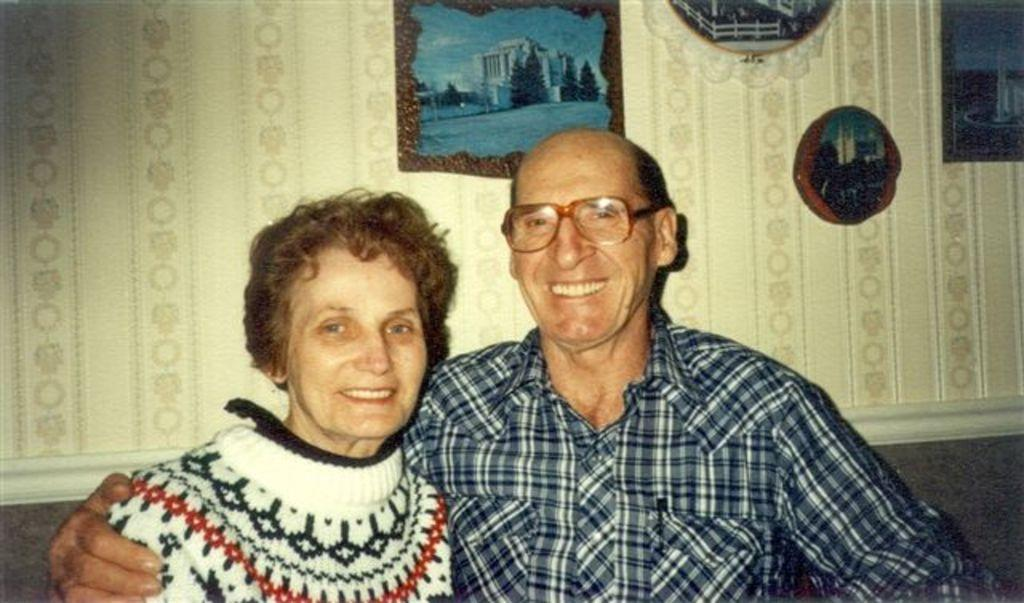Who or what can be seen in the front of the image? There are persons in the front of the image. What is the facial expression of the persons in the image? The persons are smiling. What can be seen on the wall in the background of the image? There are frames on the wall in the background of the image. How many oranges are hanging from the frames on the wall in the image? There are no oranges present in the image; the frames on the wall do not contain any oranges. 